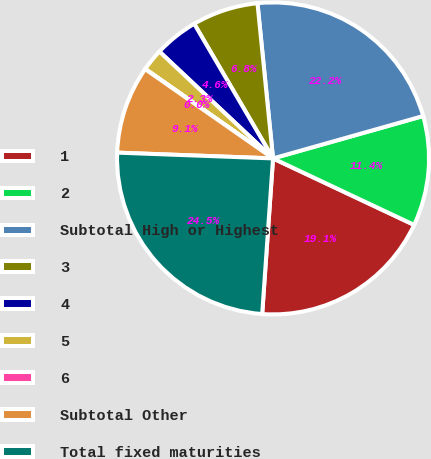Convert chart to OTSL. <chart><loc_0><loc_0><loc_500><loc_500><pie_chart><fcel>1<fcel>2<fcel>Subtotal High or Highest<fcel>3<fcel>4<fcel>5<fcel>6<fcel>Subtotal Other<fcel>Total fixed maturities<nl><fcel>19.1%<fcel>11.39%<fcel>22.21%<fcel>6.84%<fcel>4.56%<fcel>2.29%<fcel>0.02%<fcel>9.11%<fcel>24.48%<nl></chart> 